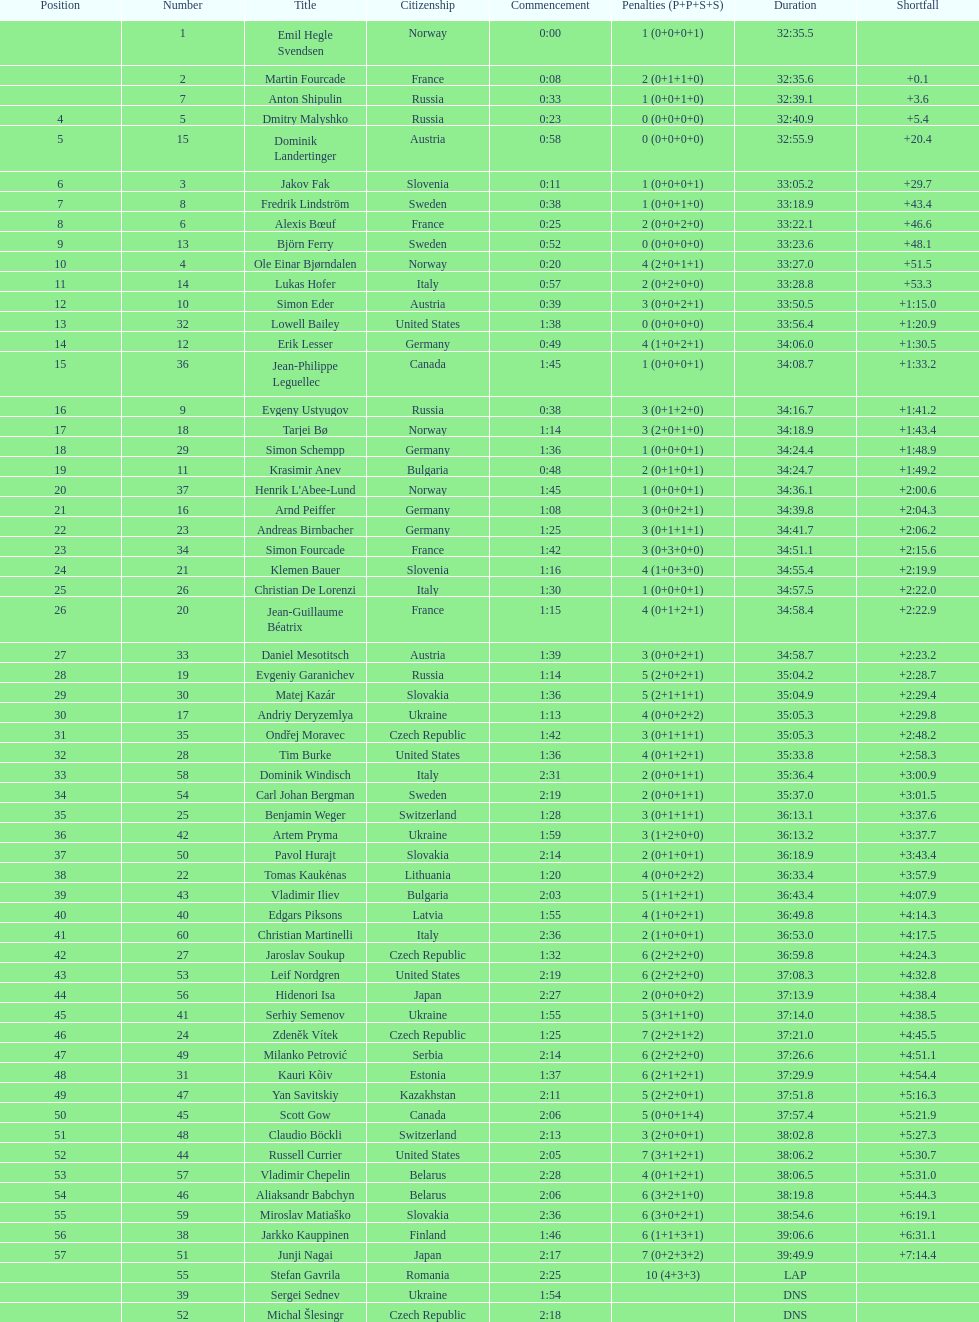Who is the top ranked runner of sweden? Fredrik Lindström. 